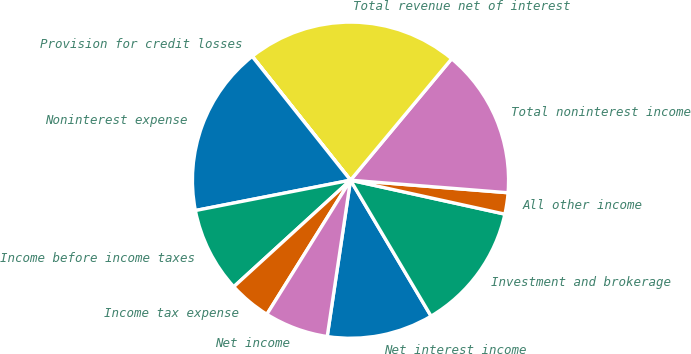Convert chart to OTSL. <chart><loc_0><loc_0><loc_500><loc_500><pie_chart><fcel>Net interest income<fcel>Investment and brokerage<fcel>All other income<fcel>Total noninterest income<fcel>Total revenue net of interest<fcel>Provision for credit losses<fcel>Noninterest expense<fcel>Income before income taxes<fcel>Income tax expense<fcel>Net income<nl><fcel>10.87%<fcel>13.04%<fcel>2.18%<fcel>15.21%<fcel>21.73%<fcel>0.01%<fcel>17.39%<fcel>8.7%<fcel>4.35%<fcel>6.52%<nl></chart> 